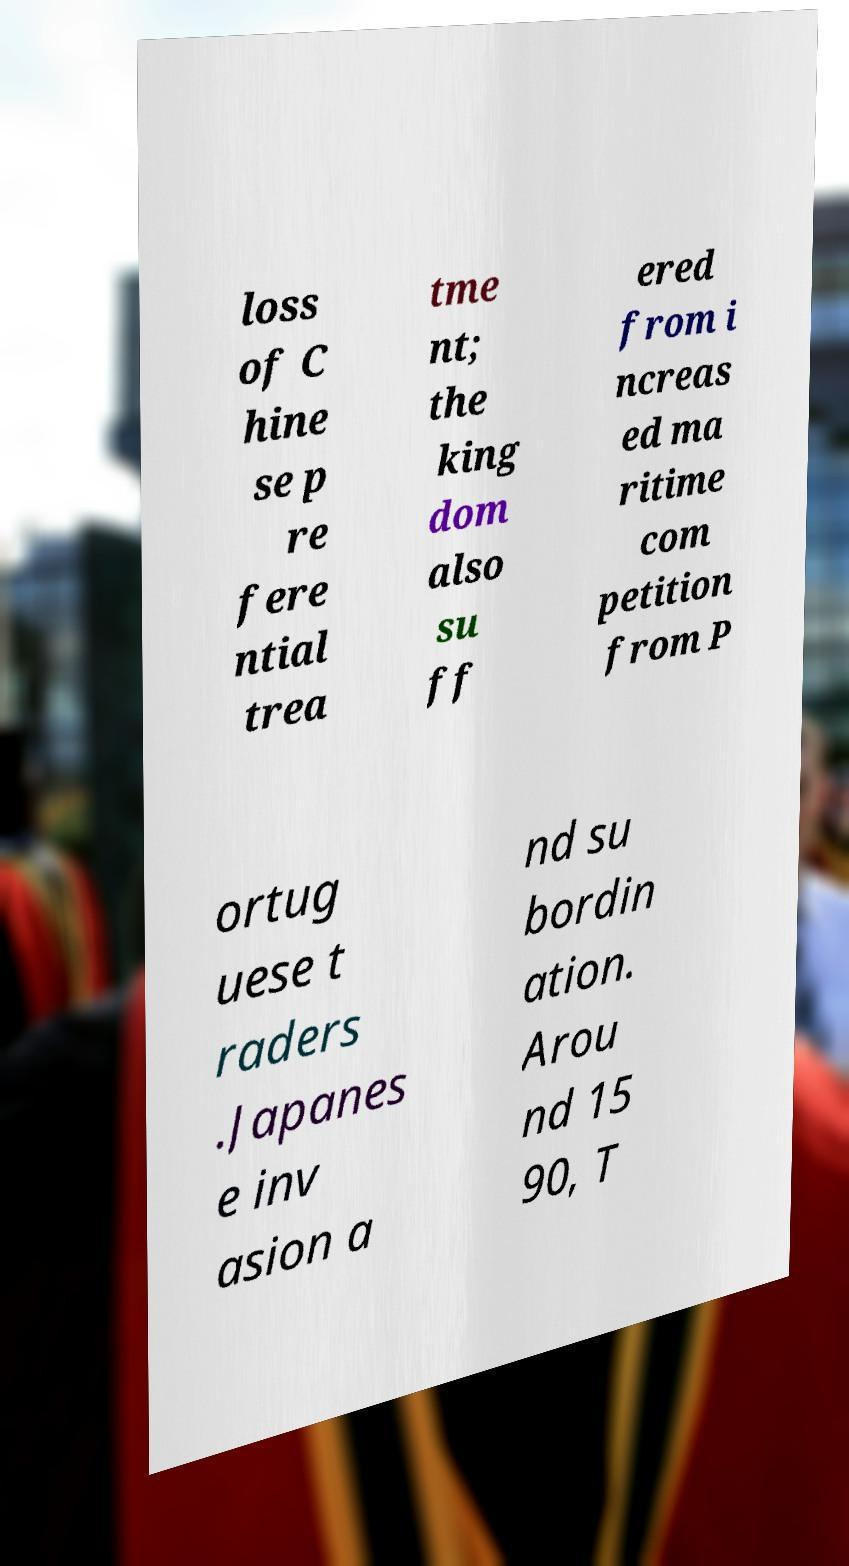Please read and relay the text visible in this image. What does it say? loss of C hine se p re fere ntial trea tme nt; the king dom also su ff ered from i ncreas ed ma ritime com petition from P ortug uese t raders .Japanes e inv asion a nd su bordin ation. Arou nd 15 90, T 